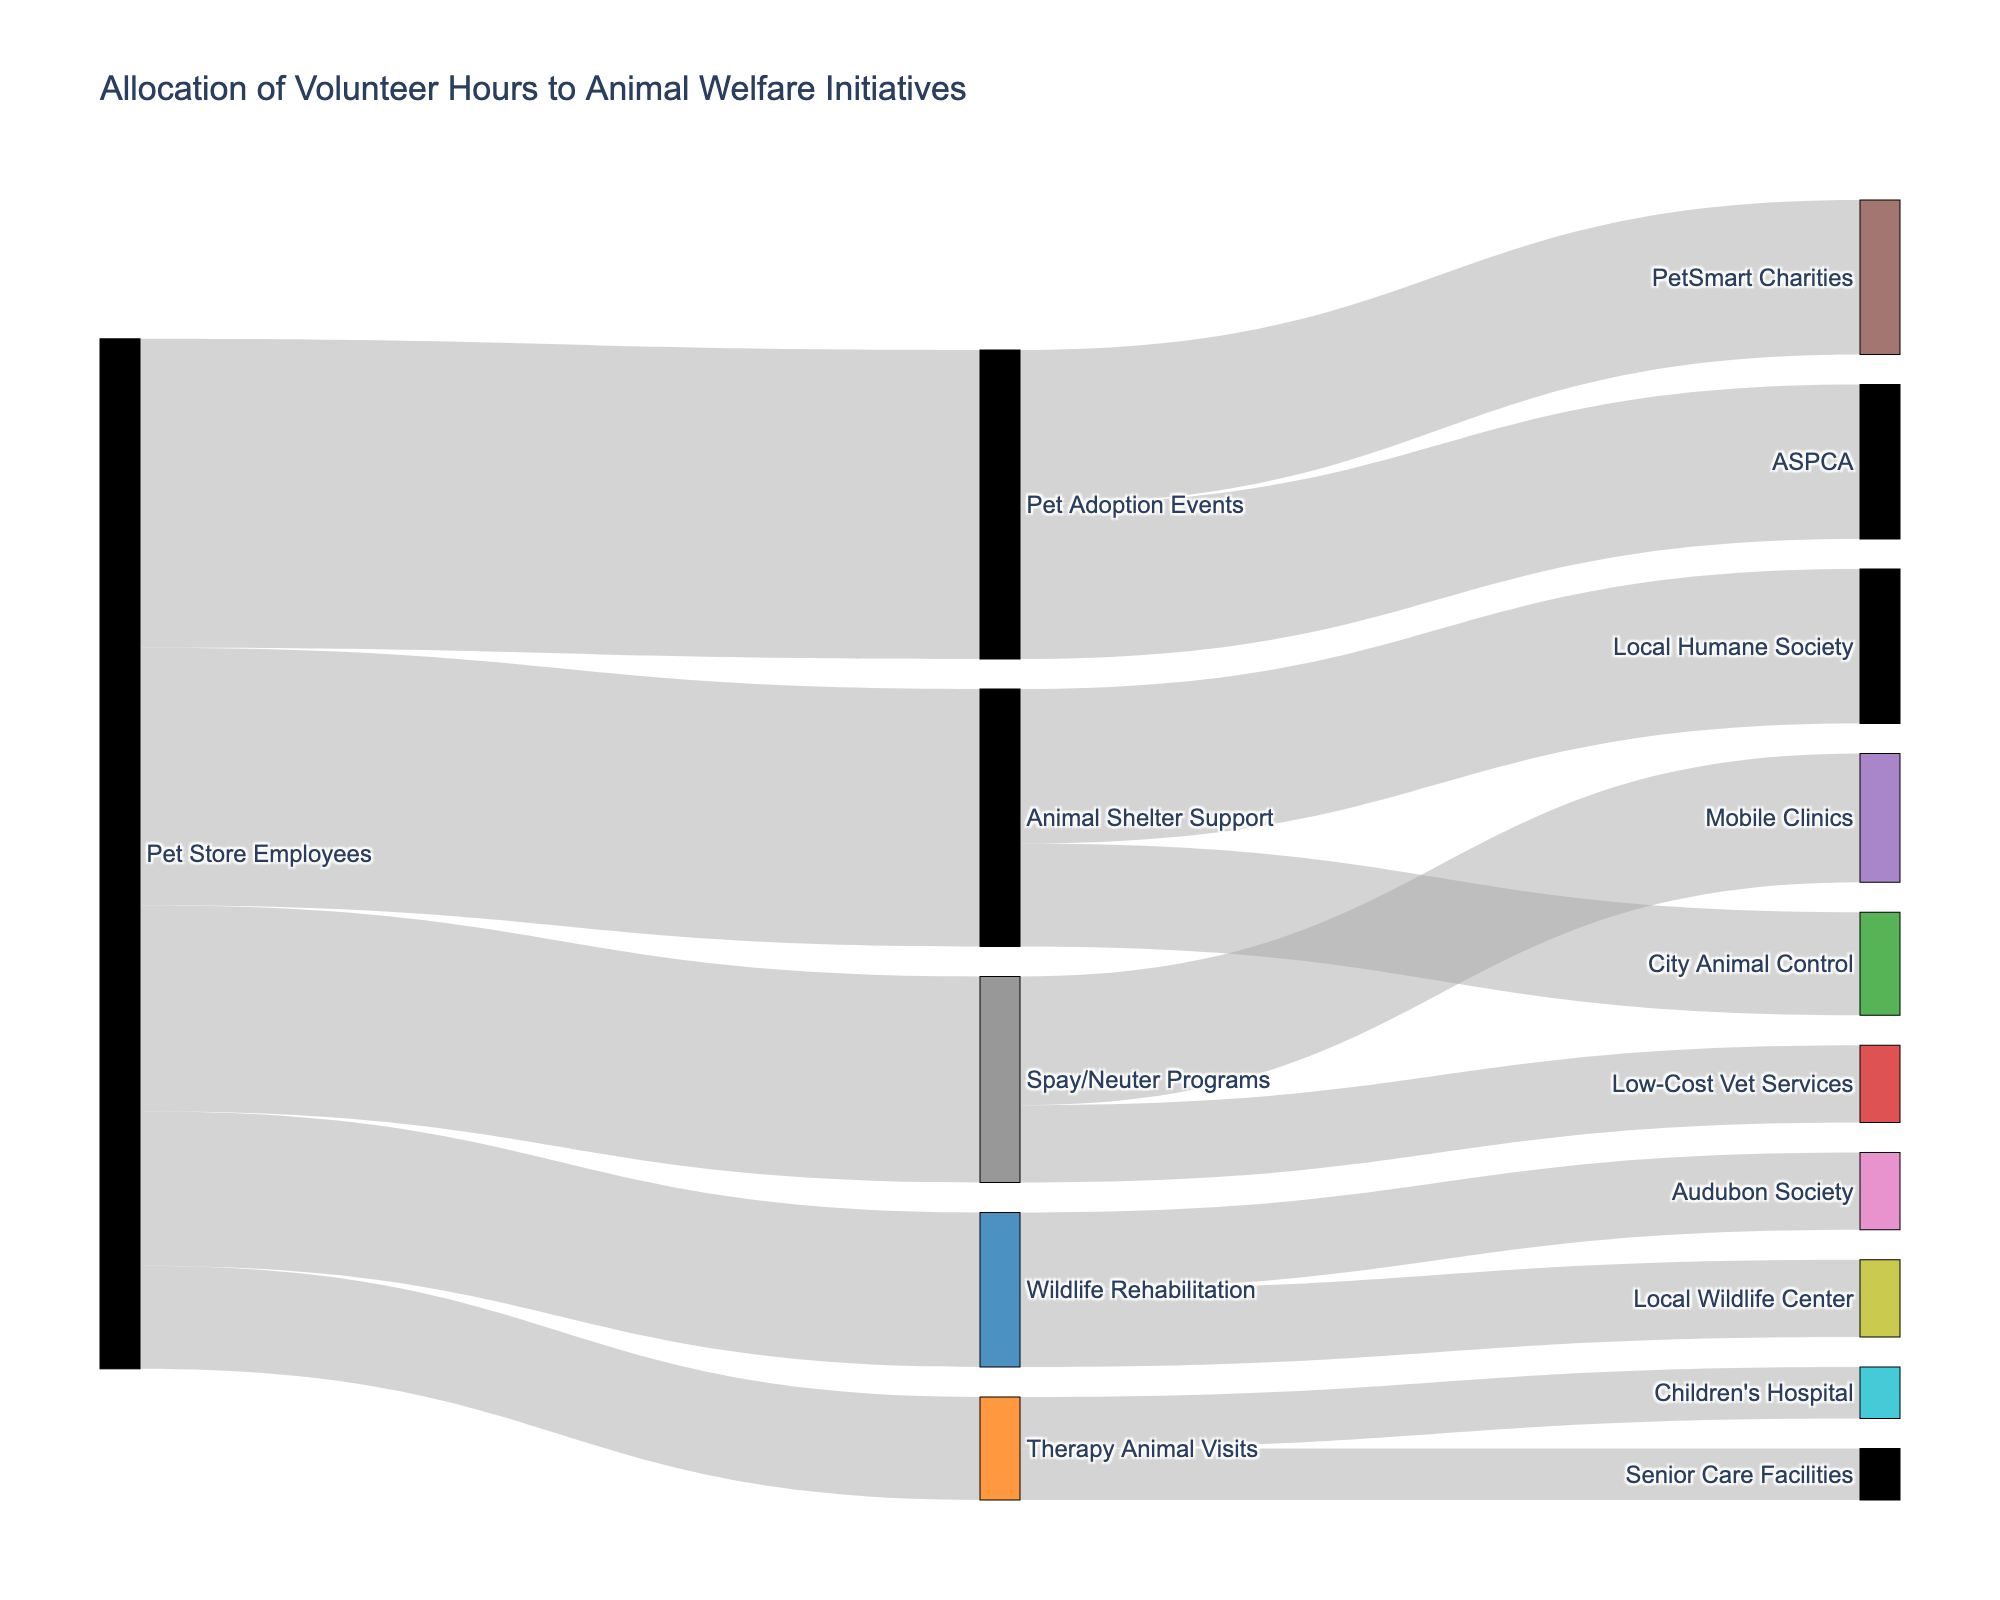What is the title of the figure? The title of the figure is displayed at the top of the Sankey diagram. It reads "Allocation of Volunteer Hours to Animal Welfare Initiatives."
Answer: Allocation of Volunteer Hours to Animal Welfare Initiatives Which community initiative receives the most volunteer hours directly from Pet Store Employees? By looking at the widths of the flows from "Pet Store Employees," we can see that "Pet Adoption Events" has the widest flow, which corresponds to 600 volunteer hours, more than any other single initiative.
Answer: Pet Adoption Events How many total volunteer hours are allocated to the Animal Shelter Support category? To find the total volunteer hours for the "Animal Shelter Support" category, sum the hours going to "Local Humane Society" and "City Animal Control" (300 + 200).
Answer: 500 Which initiatives under the Pet Adoption Events receive equal volunteer hours? Both "PetSmart Charities" and "ASPCA" have flows of equal width from "Pet Adoption Events," each corresponding to 300 volunteer hours.
Answer: PetSmart Charities and ASPCA What is the total number of volunteer hours allocated to Therapy Animal Visits and Wildlife Rehabilitation combined? Add the volunteer hours for "Therapy Animal Visits" (200 hours) and "Wildlife Rehabilitation" (300 hours).
Answer: 500 Which initiative receives the smallest allocation of volunteer hours from Pet Store Employees? The smallest flow from "Pet Store Employees" corresponds to "Therapy Animal Visits," which shows 200 volunteer hours.
Answer: Therapy Animal Visits Compare the total volunteer hours allocated to Mobile Clinics and Low-Cost Vet Services. Which receives more and by how much? "Mobile Clinics" receives 250 volunteer hours and "Low-Cost Vet Services" receives 150. The difference is 250 - 150 = 100 hours.
Answer: Mobile Clinics by 100 hours What is the total number of unique initiatives (end nodes) represented in the Sankey diagram? Count all unique initiatives to which volunteer hours are allocated: Local Humane Society, City Animal Control, Audubon Society, Local Wildlife Center, Mobile Clinics, Low-Cost Vet Services, PetSmart Charities, ASPCA, Children's Hospital, and Senior Care Facilities. There are 10 in total.
Answer: 10 How does the proportion of volunteer hours allocated to Spay/Neuter Programs compare to that allocated to Pet Adoption Events? Spay/Neuter Programs receive 400 hours, while Pet Adoption Events receive 600 hours. To compare, (400/600) = 2/3, meaning Spay/Neuter Programs get two-thirds the hours of Pet Adoption Events.
Answer: 2/3 